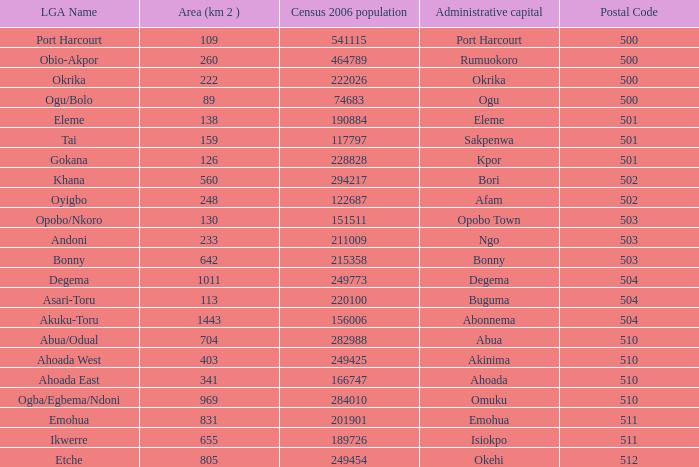What is the 2006 census population when the territory is 159? 1.0. 